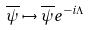<formula> <loc_0><loc_0><loc_500><loc_500>\overline { \psi } \mapsto \overline { \psi } e ^ { - i \Lambda }</formula> 